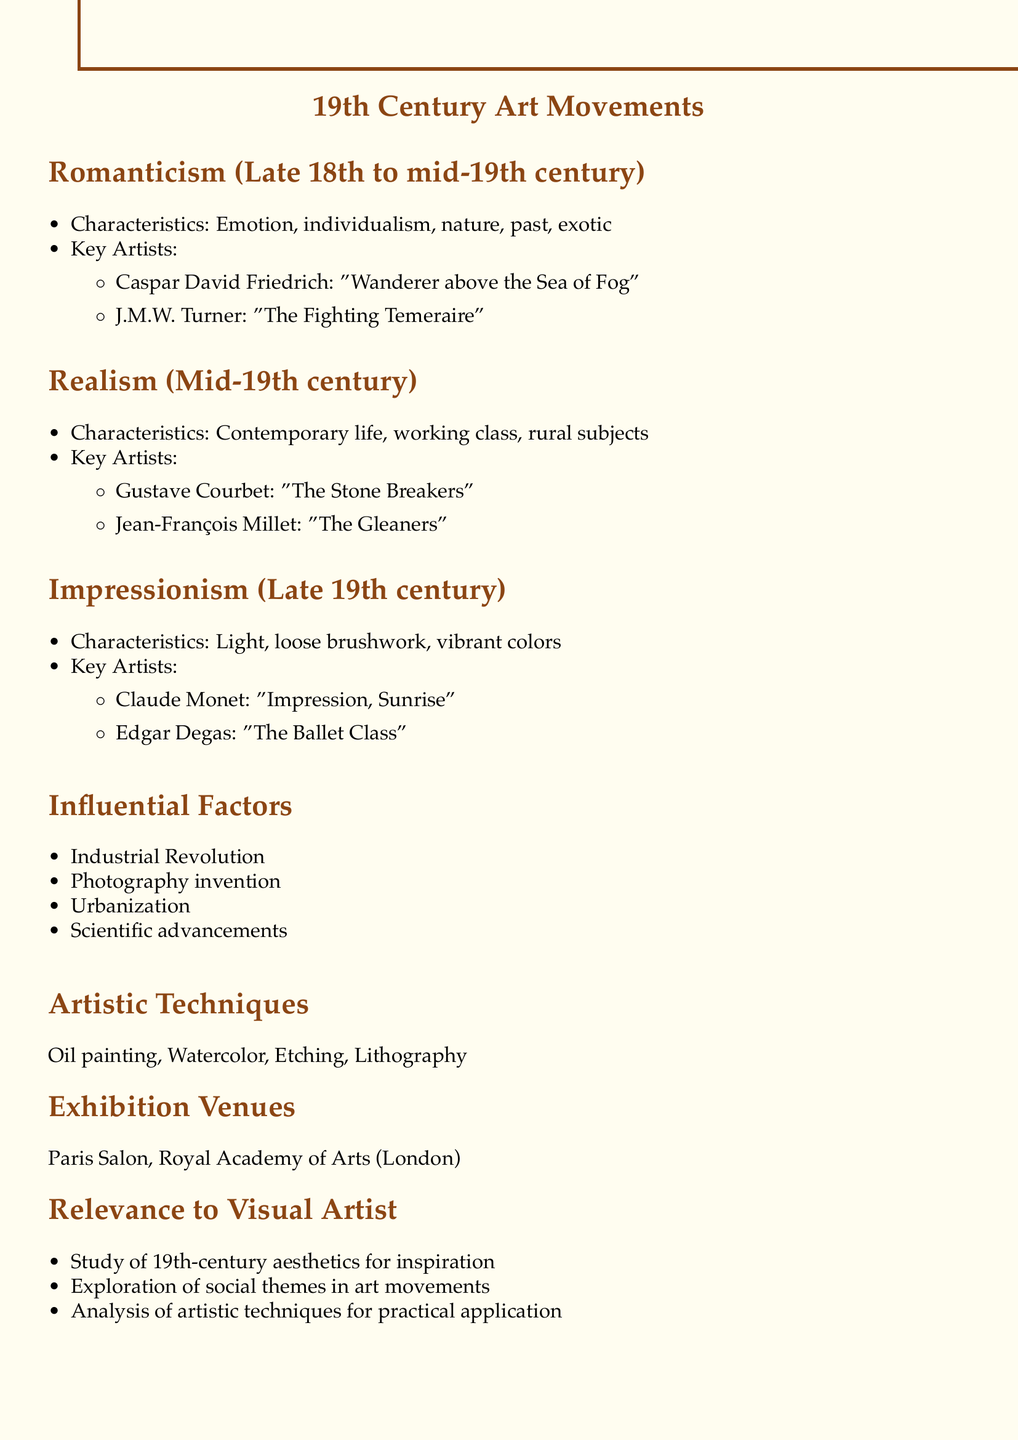What are the characteristics of Romanticism? The document lists the characteristics of Romanticism as emphasis on emotion, individualism, glorification of nature and the past, and interest in the exotic and supernatural.
Answer: Emotion, individualism, nature, past, exotic Who is a key artist associated with Realism? The document names Gustave Courbet as one of the key artists in the Realism movement.
Answer: Gustave Courbet What notable work did J.M.W. Turner create? The document specifies "The Fighting Temeraire" as a notable work by J.M.W. Turner.
Answer: The Fighting Temeraire Which technique is associated with Claude Monet? The document states that Claude Monet is known for plein air painting and color theory.
Answer: Plein air painting and color theory What period does Impressionism belong to? The document indicates that Impressionism is categorized as belonging to the late 19th century.
Answer: Late 19th century What is a common thematic focus of Realism? According to the document, Realism focuses on the accurate depiction of contemporary life, particularly working class and rural subjects.
Answer: Working class and rural subjects Which exhibition venue is mentioned for 19th-century art? The document lists the Paris Salon as one of the exhibition venues for 19th-century art.
Answer: Paris Salon What factor influenced the art movements of the 19th century? The document lists several factors, including the Industrial Revolution, which influenced 19th-century art movements.
Answer: Industrial Revolution 